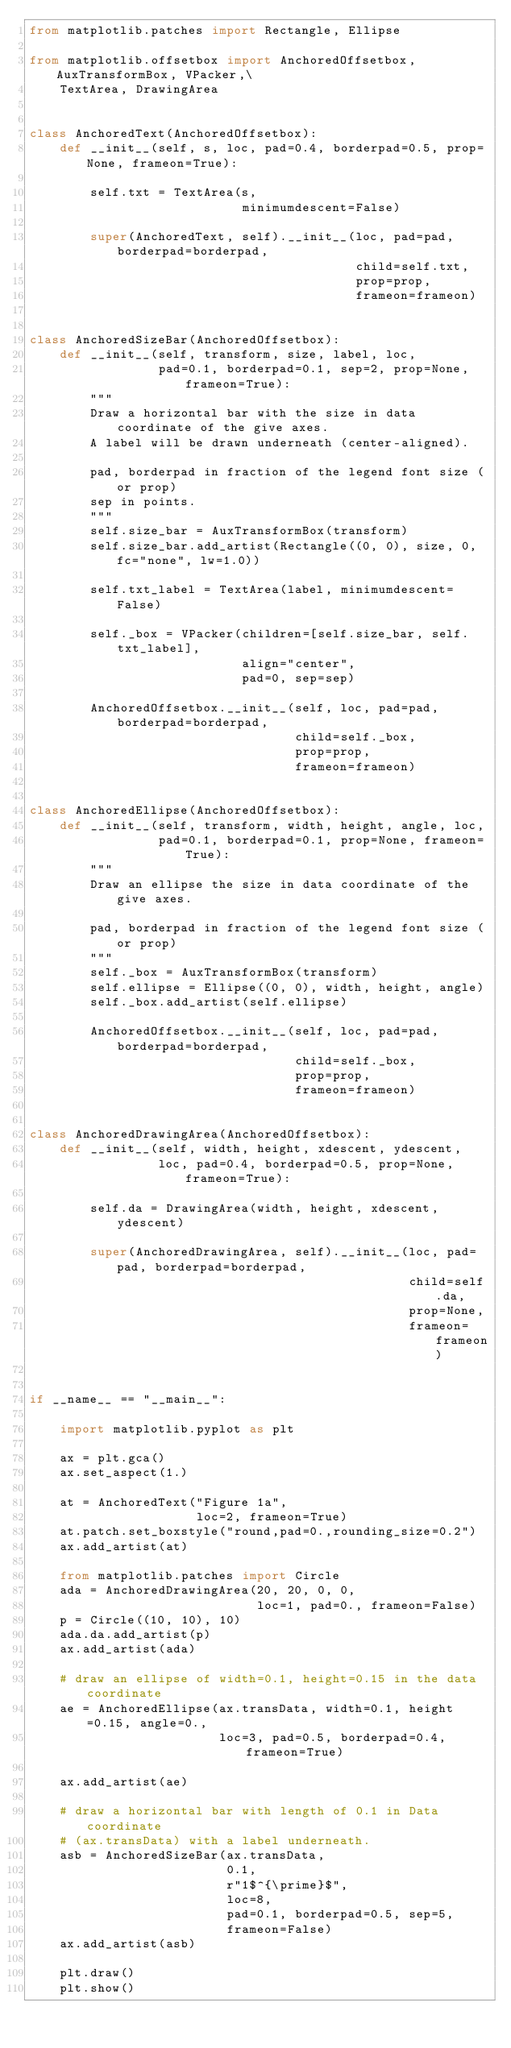Convert code to text. <code><loc_0><loc_0><loc_500><loc_500><_Python_>from matplotlib.patches import Rectangle, Ellipse

from matplotlib.offsetbox import AnchoredOffsetbox, AuxTransformBox, VPacker,\
    TextArea, DrawingArea


class AnchoredText(AnchoredOffsetbox):
    def __init__(self, s, loc, pad=0.4, borderpad=0.5, prop=None, frameon=True):

        self.txt = TextArea(s,
                            minimumdescent=False)

        super(AnchoredText, self).__init__(loc, pad=pad, borderpad=borderpad,
                                           child=self.txt,
                                           prop=prop,
                                           frameon=frameon)


class AnchoredSizeBar(AnchoredOffsetbox):
    def __init__(self, transform, size, label, loc,
                 pad=0.1, borderpad=0.1, sep=2, prop=None, frameon=True):
        """
        Draw a horizontal bar with the size in data coordinate of the give axes.
        A label will be drawn underneath (center-aligned).

        pad, borderpad in fraction of the legend font size (or prop)
        sep in points.
        """
        self.size_bar = AuxTransformBox(transform)
        self.size_bar.add_artist(Rectangle((0, 0), size, 0, fc="none", lw=1.0))

        self.txt_label = TextArea(label, minimumdescent=False)

        self._box = VPacker(children=[self.size_bar, self.txt_label],
                            align="center",
                            pad=0, sep=sep)

        AnchoredOffsetbox.__init__(self, loc, pad=pad, borderpad=borderpad,
                                   child=self._box,
                                   prop=prop,
                                   frameon=frameon)


class AnchoredEllipse(AnchoredOffsetbox):
    def __init__(self, transform, width, height, angle, loc,
                 pad=0.1, borderpad=0.1, prop=None, frameon=True):
        """
        Draw an ellipse the size in data coordinate of the give axes.

        pad, borderpad in fraction of the legend font size (or prop)
        """
        self._box = AuxTransformBox(transform)
        self.ellipse = Ellipse((0, 0), width, height, angle)
        self._box.add_artist(self.ellipse)

        AnchoredOffsetbox.__init__(self, loc, pad=pad, borderpad=borderpad,
                                   child=self._box,
                                   prop=prop,
                                   frameon=frameon)


class AnchoredDrawingArea(AnchoredOffsetbox):
    def __init__(self, width, height, xdescent, ydescent,
                 loc, pad=0.4, borderpad=0.5, prop=None, frameon=True):

        self.da = DrawingArea(width, height, xdescent, ydescent)

        super(AnchoredDrawingArea, self).__init__(loc, pad=pad, borderpad=borderpad,
                                                  child=self.da,
                                                  prop=None,
                                                  frameon=frameon)


if __name__ == "__main__":

    import matplotlib.pyplot as plt

    ax = plt.gca()
    ax.set_aspect(1.)

    at = AnchoredText("Figure 1a",
                      loc=2, frameon=True)
    at.patch.set_boxstyle("round,pad=0.,rounding_size=0.2")
    ax.add_artist(at)

    from matplotlib.patches import Circle
    ada = AnchoredDrawingArea(20, 20, 0, 0,
                              loc=1, pad=0., frameon=False)
    p = Circle((10, 10), 10)
    ada.da.add_artist(p)
    ax.add_artist(ada)

    # draw an ellipse of width=0.1, height=0.15 in the data coordinate
    ae = AnchoredEllipse(ax.transData, width=0.1, height=0.15, angle=0.,
                         loc=3, pad=0.5, borderpad=0.4, frameon=True)

    ax.add_artist(ae)

    # draw a horizontal bar with length of 0.1 in Data coordinate
    # (ax.transData) with a label underneath.
    asb = AnchoredSizeBar(ax.transData,
                          0.1,
                          r"1$^{\prime}$",
                          loc=8,
                          pad=0.1, borderpad=0.5, sep=5,
                          frameon=False)
    ax.add_artist(asb)

    plt.draw()
    plt.show()
</code> 